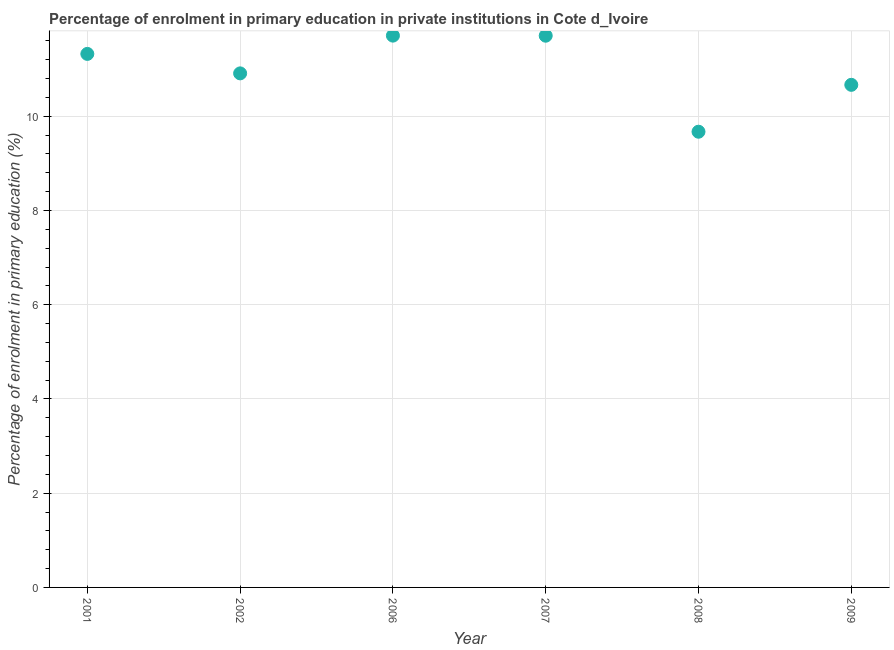What is the enrolment percentage in primary education in 2001?
Give a very brief answer. 11.32. Across all years, what is the maximum enrolment percentage in primary education?
Your response must be concise. 11.71. Across all years, what is the minimum enrolment percentage in primary education?
Your response must be concise. 9.67. In which year was the enrolment percentage in primary education minimum?
Provide a short and direct response. 2008. What is the sum of the enrolment percentage in primary education?
Your response must be concise. 65.99. What is the difference between the enrolment percentage in primary education in 2001 and 2009?
Ensure brevity in your answer.  0.66. What is the average enrolment percentage in primary education per year?
Give a very brief answer. 11. What is the median enrolment percentage in primary education?
Offer a very short reply. 11.12. In how many years, is the enrolment percentage in primary education greater than 7.6 %?
Ensure brevity in your answer.  6. Do a majority of the years between 2009 and 2002 (inclusive) have enrolment percentage in primary education greater than 8 %?
Offer a very short reply. Yes. What is the ratio of the enrolment percentage in primary education in 2008 to that in 2009?
Your response must be concise. 0.91. What is the difference between the highest and the second highest enrolment percentage in primary education?
Give a very brief answer. 0. Is the sum of the enrolment percentage in primary education in 2001 and 2006 greater than the maximum enrolment percentage in primary education across all years?
Your response must be concise. Yes. What is the difference between the highest and the lowest enrolment percentage in primary education?
Keep it short and to the point. 2.04. In how many years, is the enrolment percentage in primary education greater than the average enrolment percentage in primary education taken over all years?
Offer a very short reply. 3. Does the enrolment percentage in primary education monotonically increase over the years?
Keep it short and to the point. No. How many dotlines are there?
Your response must be concise. 1. How many years are there in the graph?
Offer a terse response. 6. What is the difference between two consecutive major ticks on the Y-axis?
Provide a succinct answer. 2. Are the values on the major ticks of Y-axis written in scientific E-notation?
Your answer should be compact. No. Does the graph contain any zero values?
Keep it short and to the point. No. What is the title of the graph?
Ensure brevity in your answer.  Percentage of enrolment in primary education in private institutions in Cote d_Ivoire. What is the label or title of the X-axis?
Ensure brevity in your answer.  Year. What is the label or title of the Y-axis?
Offer a very short reply. Percentage of enrolment in primary education (%). What is the Percentage of enrolment in primary education (%) in 2001?
Your answer should be very brief. 11.32. What is the Percentage of enrolment in primary education (%) in 2002?
Your response must be concise. 10.91. What is the Percentage of enrolment in primary education (%) in 2006?
Keep it short and to the point. 11.71. What is the Percentage of enrolment in primary education (%) in 2007?
Offer a terse response. 11.71. What is the Percentage of enrolment in primary education (%) in 2008?
Provide a succinct answer. 9.67. What is the Percentage of enrolment in primary education (%) in 2009?
Your response must be concise. 10.67. What is the difference between the Percentage of enrolment in primary education (%) in 2001 and 2002?
Give a very brief answer. 0.41. What is the difference between the Percentage of enrolment in primary education (%) in 2001 and 2006?
Provide a short and direct response. -0.39. What is the difference between the Percentage of enrolment in primary education (%) in 2001 and 2007?
Provide a succinct answer. -0.39. What is the difference between the Percentage of enrolment in primary education (%) in 2001 and 2008?
Ensure brevity in your answer.  1.65. What is the difference between the Percentage of enrolment in primary education (%) in 2001 and 2009?
Provide a succinct answer. 0.66. What is the difference between the Percentage of enrolment in primary education (%) in 2002 and 2006?
Make the answer very short. -0.8. What is the difference between the Percentage of enrolment in primary education (%) in 2002 and 2007?
Your answer should be very brief. -0.8. What is the difference between the Percentage of enrolment in primary education (%) in 2002 and 2008?
Your response must be concise. 1.24. What is the difference between the Percentage of enrolment in primary education (%) in 2002 and 2009?
Provide a short and direct response. 0.24. What is the difference between the Percentage of enrolment in primary education (%) in 2006 and 2007?
Offer a very short reply. 0. What is the difference between the Percentage of enrolment in primary education (%) in 2006 and 2008?
Ensure brevity in your answer.  2.04. What is the difference between the Percentage of enrolment in primary education (%) in 2006 and 2009?
Provide a short and direct response. 1.04. What is the difference between the Percentage of enrolment in primary education (%) in 2007 and 2008?
Your answer should be very brief. 2.04. What is the difference between the Percentage of enrolment in primary education (%) in 2007 and 2009?
Offer a terse response. 1.04. What is the difference between the Percentage of enrolment in primary education (%) in 2008 and 2009?
Provide a succinct answer. -1. What is the ratio of the Percentage of enrolment in primary education (%) in 2001 to that in 2002?
Provide a short and direct response. 1.04. What is the ratio of the Percentage of enrolment in primary education (%) in 2001 to that in 2006?
Make the answer very short. 0.97. What is the ratio of the Percentage of enrolment in primary education (%) in 2001 to that in 2007?
Your answer should be compact. 0.97. What is the ratio of the Percentage of enrolment in primary education (%) in 2001 to that in 2008?
Ensure brevity in your answer.  1.17. What is the ratio of the Percentage of enrolment in primary education (%) in 2001 to that in 2009?
Provide a succinct answer. 1.06. What is the ratio of the Percentage of enrolment in primary education (%) in 2002 to that in 2006?
Provide a succinct answer. 0.93. What is the ratio of the Percentage of enrolment in primary education (%) in 2002 to that in 2007?
Provide a succinct answer. 0.93. What is the ratio of the Percentage of enrolment in primary education (%) in 2002 to that in 2008?
Provide a succinct answer. 1.13. What is the ratio of the Percentage of enrolment in primary education (%) in 2006 to that in 2008?
Keep it short and to the point. 1.21. What is the ratio of the Percentage of enrolment in primary education (%) in 2006 to that in 2009?
Provide a succinct answer. 1.1. What is the ratio of the Percentage of enrolment in primary education (%) in 2007 to that in 2008?
Provide a succinct answer. 1.21. What is the ratio of the Percentage of enrolment in primary education (%) in 2007 to that in 2009?
Offer a terse response. 1.1. What is the ratio of the Percentage of enrolment in primary education (%) in 2008 to that in 2009?
Ensure brevity in your answer.  0.91. 